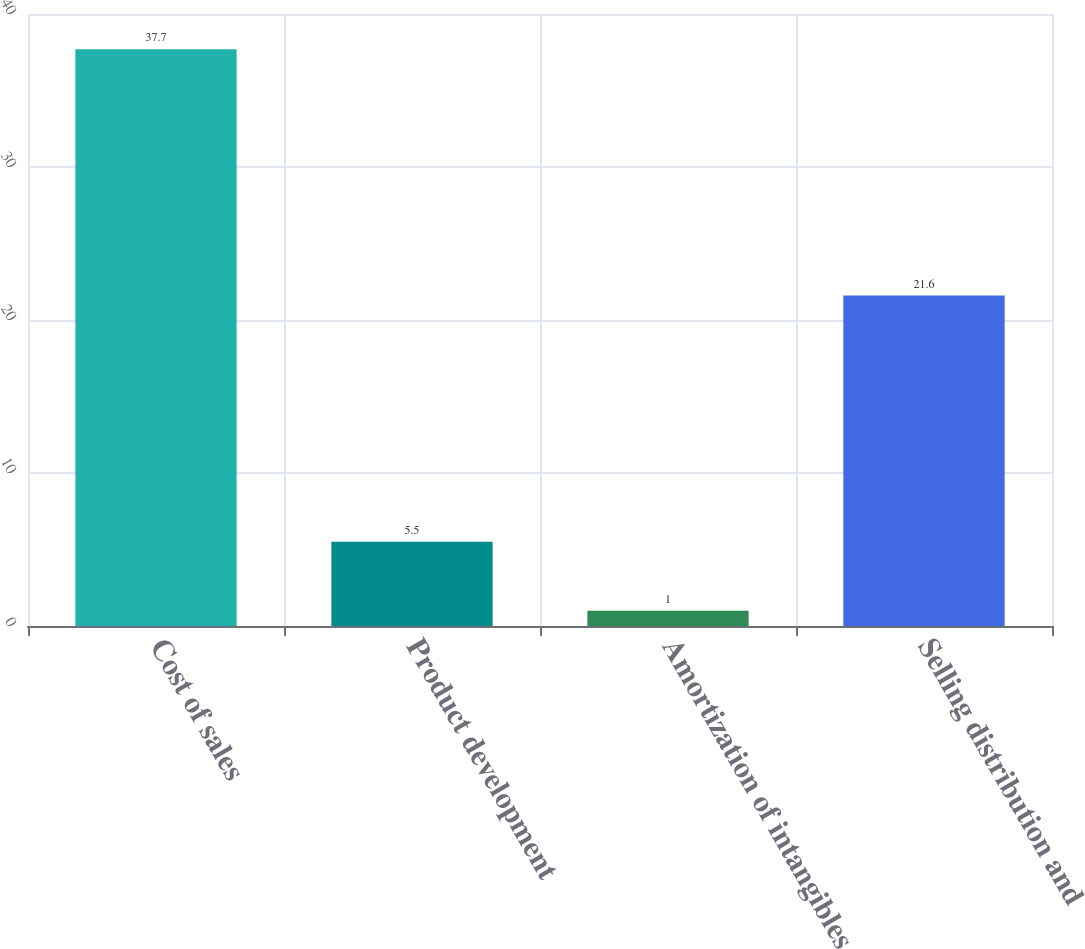<chart> <loc_0><loc_0><loc_500><loc_500><bar_chart><fcel>Cost of sales<fcel>Product development<fcel>Amortization of intangibles<fcel>Selling distribution and<nl><fcel>37.7<fcel>5.5<fcel>1<fcel>21.6<nl></chart> 